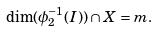<formula> <loc_0><loc_0><loc_500><loc_500>\dim ( \phi _ { 2 } ^ { - 1 } ( I ) ) \cap X = m .</formula> 